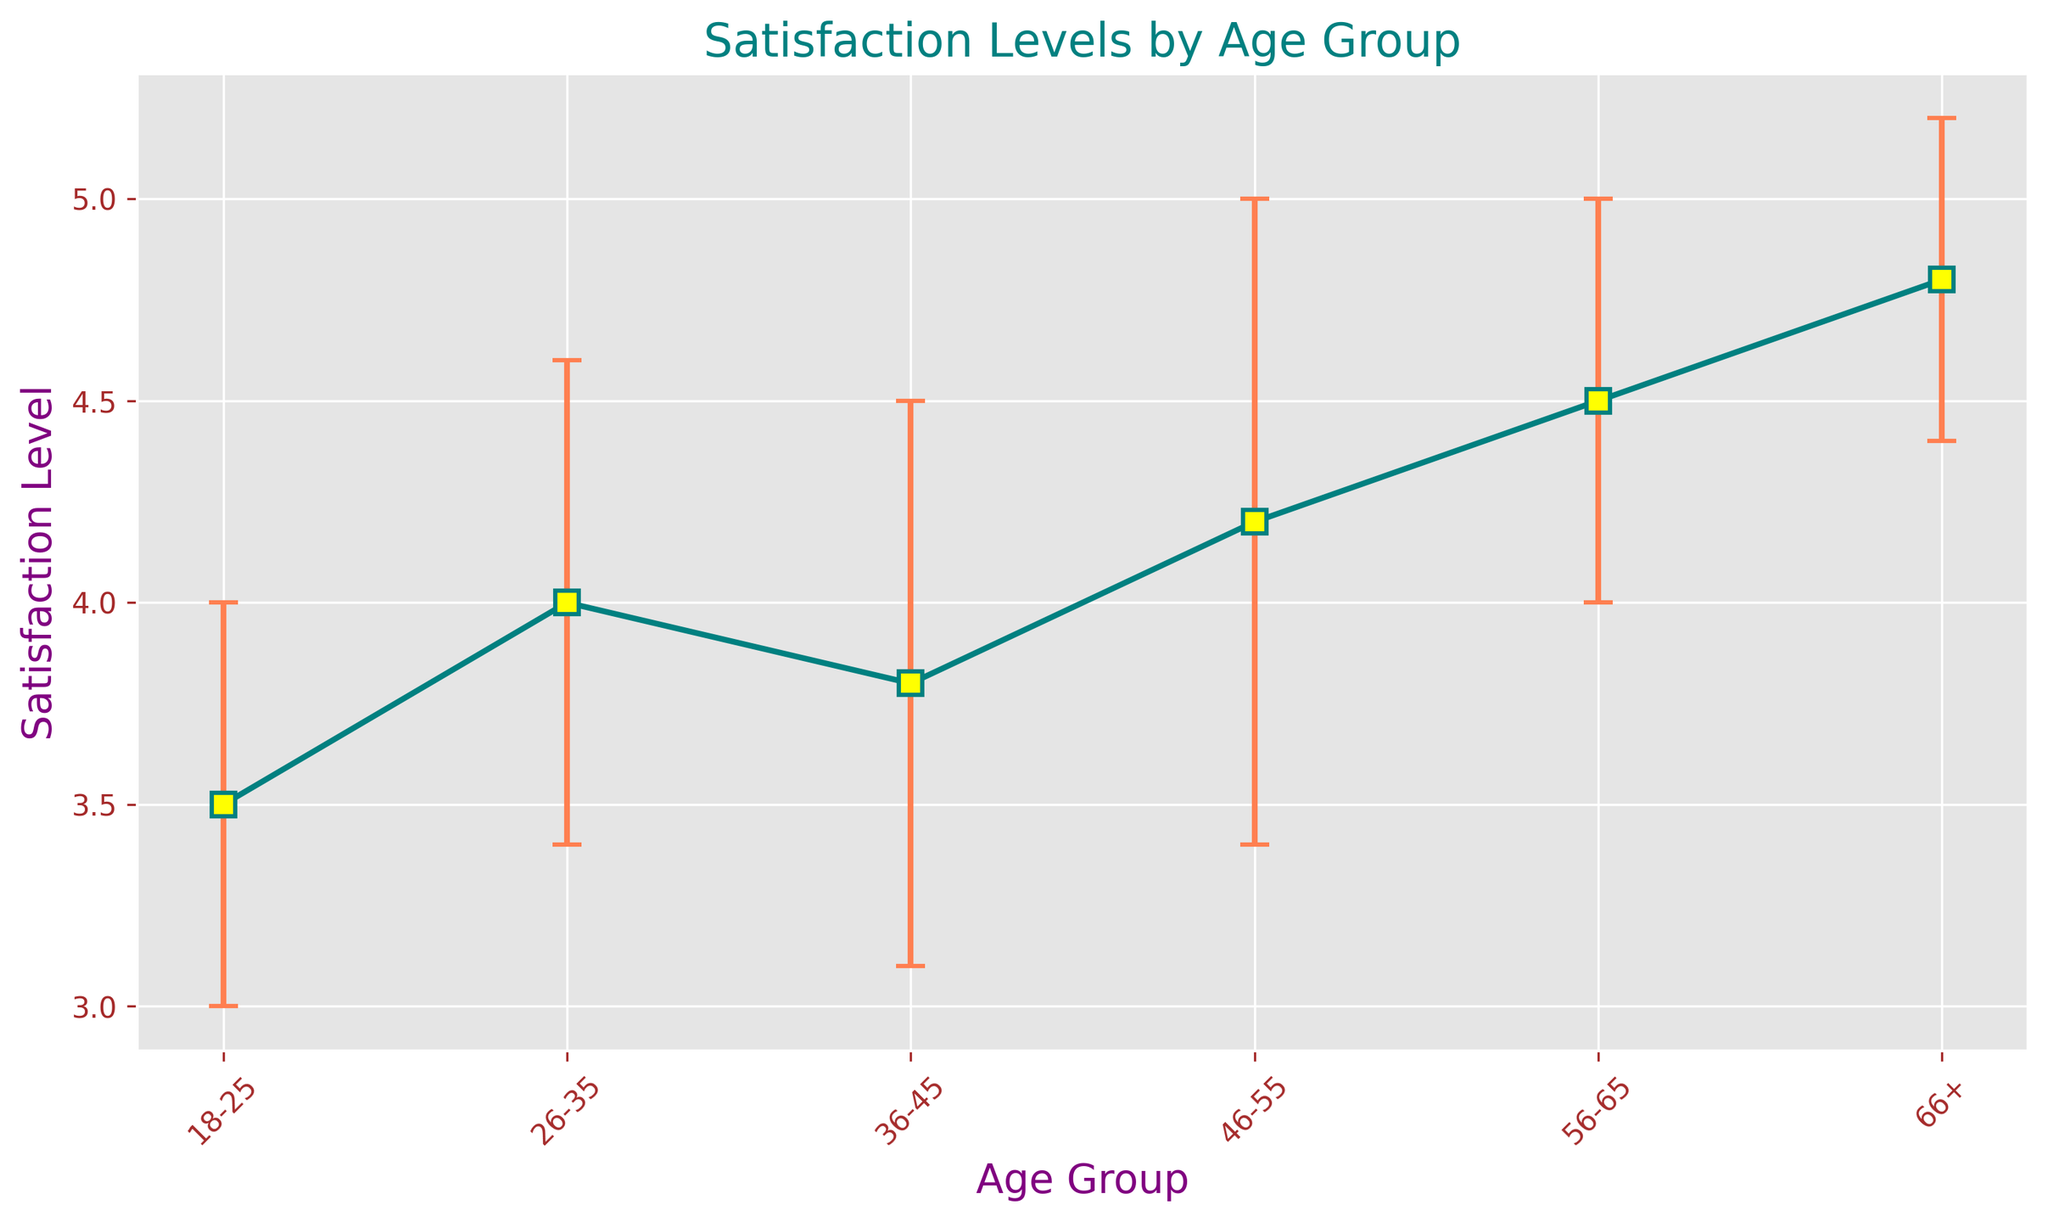How does the satisfaction level of the oldest age group compare to the youngest age group? The oldest age group (66+) has a satisfaction mean of 4.8, while the youngest age group (18-25) has a satisfaction mean of 3.5. Therefore, the older age group has a higher satisfaction level compared to the younger group.
Answer: The oldest age group has a higher satisfaction level Which age group shows the least variance in satisfaction levels? The standard deviation of satisfaction levels indicates variance. The 66+ age group has a standard deviation of 0.4, which is the smallest among all groups.
Answer: 66+ age group What is the average satisfaction level across all age groups? Add the means of all age groups and divide by the number of groups: (3.5 + 4.0 + 3.8 + 4.2 + 4.5 + 4.8) / 6 = 4.13.
Answer: 4.13 How does the satisfaction level of the age group 26-35 compare to the age group 36-45? The 26-35 age group has a mean satisfaction level of 4.0, while the 36-45 age group has a mean satisfaction level of 3.8. Therefore, the 26-35 age group is slightly more satisfied.
Answer: 26-35 age group is more satisfied Which age group has the highest satisfaction level and by how much does it exceed the second highest group? The 66+ age group has the highest satisfaction level at 4.8. The second highest is the 56-65 age group at 4.5. The difference is 4.8 - 4.5 = 0.3.
Answer: 66+ age group by 0.3 By how much does the satisfaction level of the age group 46-55 differ from the overall average satisfaction level? The mean satisfaction level for the 46-55 age group is 4.2. The overall average satisfaction level is 4.13. The difference is 4.2 - 4.13 = 0.07.
Answer: 0.07 Between which two adjacent age groups is the change in satisfaction levels the largest? Evaluate the differences between adjacent age groups: 
18-25 to 26-35: 4.0 - 3.5 = 0.5,
26-35 to 36-45: 4.0 - 3.8 = 0.2,
36-45 to 46-55: 4.2 - 3.8 = 0.4,
46-55 to 56-65: 4.5 - 4.2 = 0.3,
56-65 to 66+: 4.8 - 4.5 = 0.3.
The largest change is between 18-25 and 26-35 (0.5).
Answer: 18-25 to 26-35 Which age group has the highest uncertainty in satisfaction levels and what does it indicate? The standard deviation indicates uncertainty. The age group 46-55 has the highest standard deviation at 0.8, indicating the responses in this group are more spread out around the mean.
Answer: 46-55 age group Do older age groups generally have higher satisfaction levels compared to younger ones? By observing the general trend in the plot, satisfaction levels increase with age, with the highest levels in the 66+ group and the lowest in the 18-25 group.
Answer: Yes, they do 